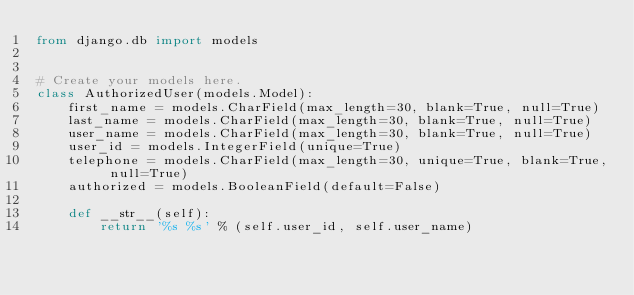Convert code to text. <code><loc_0><loc_0><loc_500><loc_500><_Python_>from django.db import models


# Create your models here.
class AuthorizedUser(models.Model):
    first_name = models.CharField(max_length=30, blank=True, null=True)
    last_name = models.CharField(max_length=30, blank=True, null=True)
    user_name = models.CharField(max_length=30, blank=True, null=True)
    user_id = models.IntegerField(unique=True)
    telephone = models.CharField(max_length=30, unique=True, blank=True, null=True)
    authorized = models.BooleanField(default=False)

    def __str__(self):
        return '%s %s' % (self.user_id, self.user_name)
</code> 